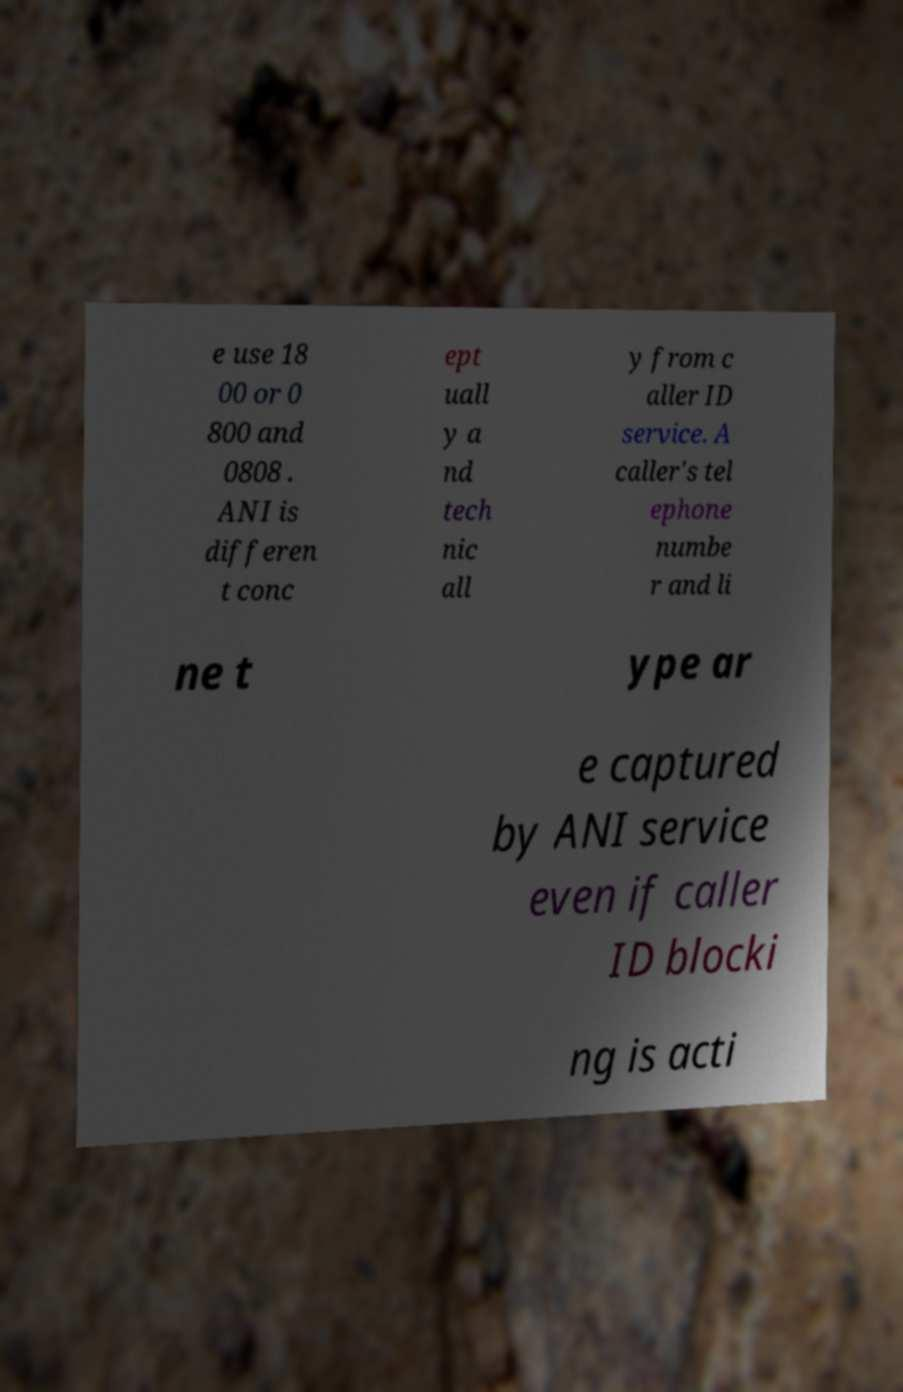Could you extract and type out the text from this image? e use 18 00 or 0 800 and 0808 . ANI is differen t conc ept uall y a nd tech nic all y from c aller ID service. A caller's tel ephone numbe r and li ne t ype ar e captured by ANI service even if caller ID blocki ng is acti 